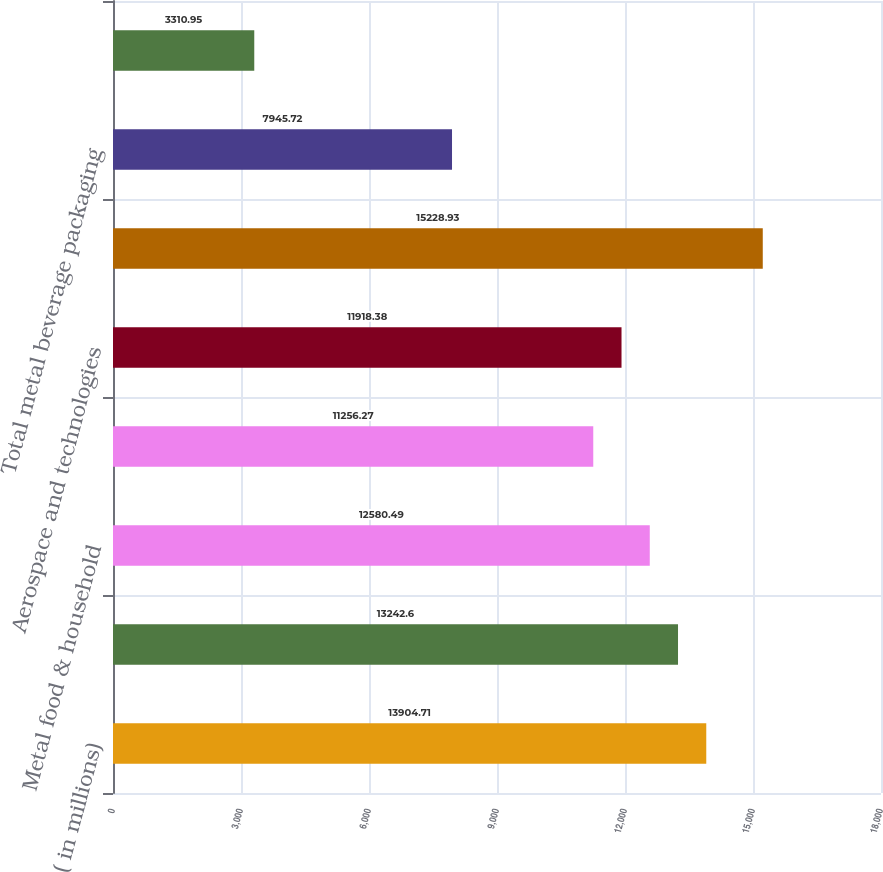Convert chart to OTSL. <chart><loc_0><loc_0><loc_500><loc_500><bar_chart><fcel>( in millions)<fcel>Metal beverage packaging<fcel>Metal food & household<fcel>Plastic packaging Americas<fcel>Aerospace and technologies<fcel>Net sales<fcel>Total metal beverage packaging<fcel>Business consolidation (costs)<nl><fcel>13904.7<fcel>13242.6<fcel>12580.5<fcel>11256.3<fcel>11918.4<fcel>15228.9<fcel>7945.72<fcel>3310.95<nl></chart> 